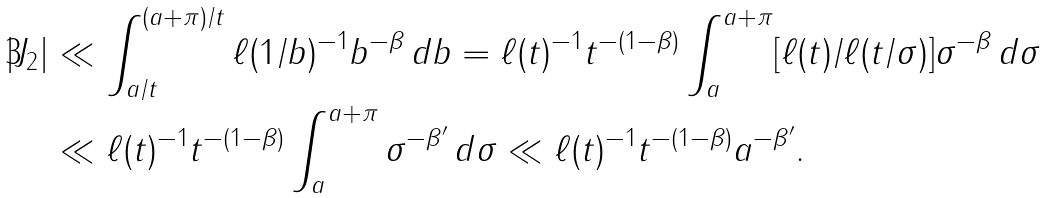<formula> <loc_0><loc_0><loc_500><loc_500>| J _ { 2 } | & \ll \int _ { a / t } ^ { ( a + \pi ) / t } \ell ( 1 / b ) ^ { - 1 } b ^ { - \beta } \, d b = \ell ( t ) ^ { - 1 } t ^ { - ( 1 - \beta ) } \int _ { a } ^ { a + \pi } [ \ell ( t ) / \ell ( t / \sigma ) ] \sigma ^ { - \beta } \, d \sigma \\ & \ll \ell ( t ) ^ { - 1 } t ^ { - ( 1 - \beta ) } \int _ { a } ^ { a + \pi } \sigma ^ { - \beta ^ { \prime } } \, d \sigma \ll \ell ( t ) ^ { - 1 } t ^ { - ( 1 - \beta ) } a ^ { - \beta ^ { \prime } } .</formula> 